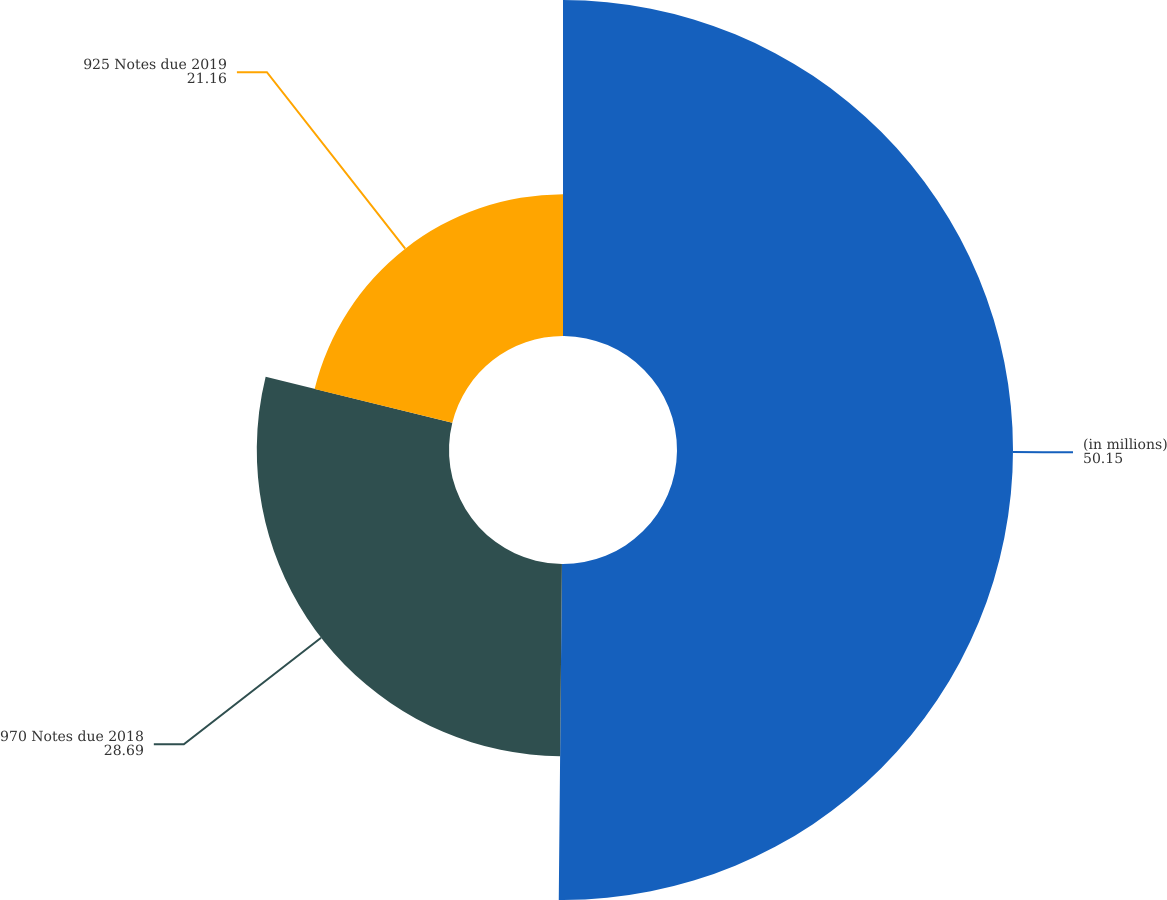Convert chart. <chart><loc_0><loc_0><loc_500><loc_500><pie_chart><fcel>(in millions)<fcel>970 Notes due 2018<fcel>925 Notes due 2019<nl><fcel>50.15%<fcel>28.69%<fcel>21.16%<nl></chart> 